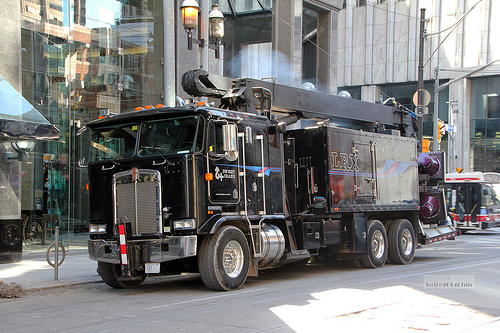<image>
Is there a truck above the road? No. The truck is not positioned above the road. The vertical arrangement shows a different relationship. 